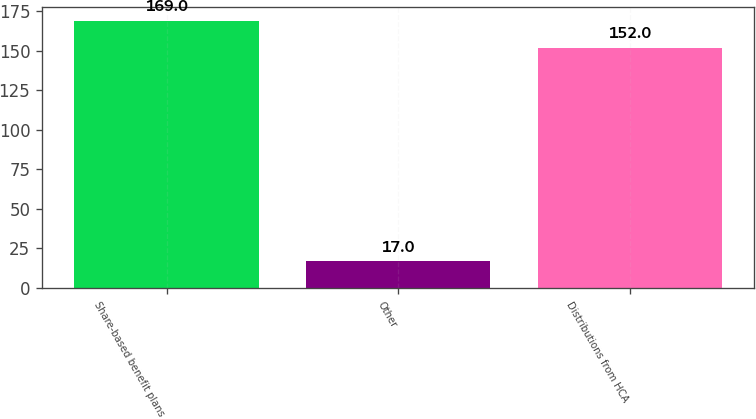<chart> <loc_0><loc_0><loc_500><loc_500><bar_chart><fcel>Share-based benefit plans<fcel>Other<fcel>Distributions from HCA<nl><fcel>169<fcel>17<fcel>152<nl></chart> 